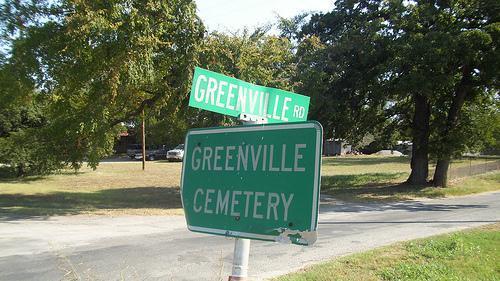How many signposts do you see?
Give a very brief answer. 1. How many signs do you see?
Give a very brief answer. 2. 